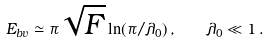Convert formula to latex. <formula><loc_0><loc_0><loc_500><loc_500>E _ { b v } \simeq \pi \sqrt { F } \ln ( \pi / \lambda _ { 0 } ) \, , \quad \lambda _ { 0 } \ll 1 \, .</formula> 